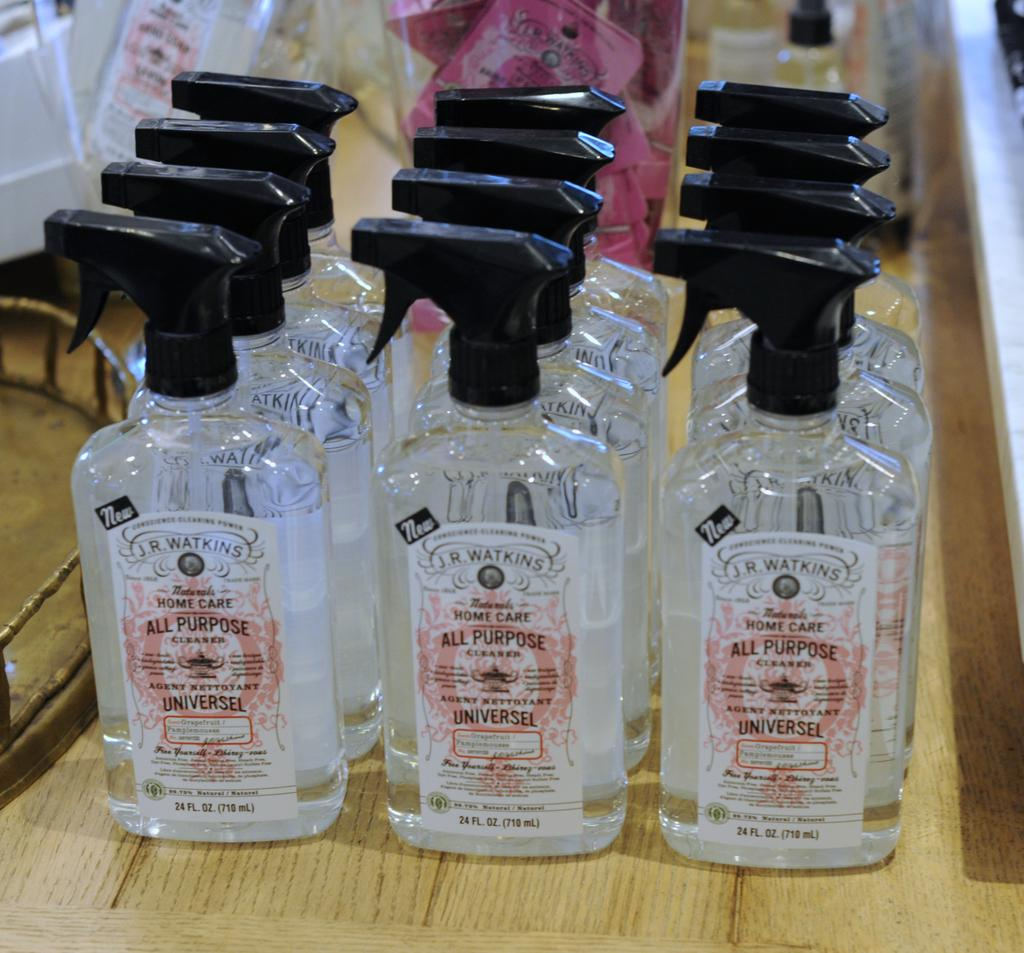What objects are present in the image? There are spray bottles in the image. What is the surface on which the spray bottles are placed? The spray bottles are on a wooden surface. What type of bomb is hidden under the wooden surface in the image? There is no bomb present in the image; it only features spray bottles on a wooden surface. 